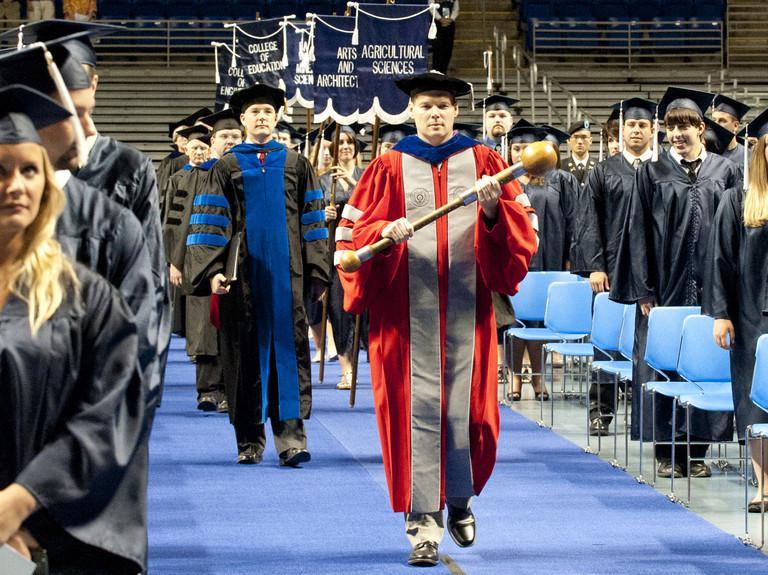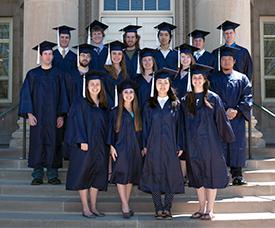The first image is the image on the left, the second image is the image on the right. For the images displayed, is the sentence "There is a group of students walking in a line in the left image." factually correct? Answer yes or no. Yes. 